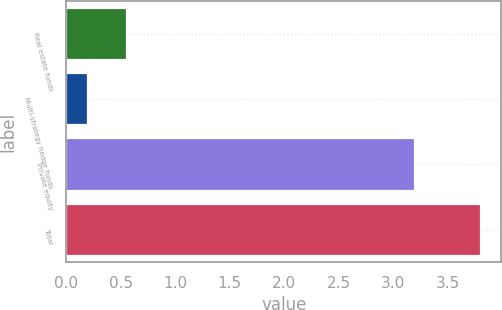<chart> <loc_0><loc_0><loc_500><loc_500><bar_chart><fcel>Real estate funds<fcel>Multi-strategy hedge funds<fcel>Private equity<fcel>Total<nl><fcel>0.56<fcel>0.2<fcel>3.2<fcel>3.8<nl></chart> 